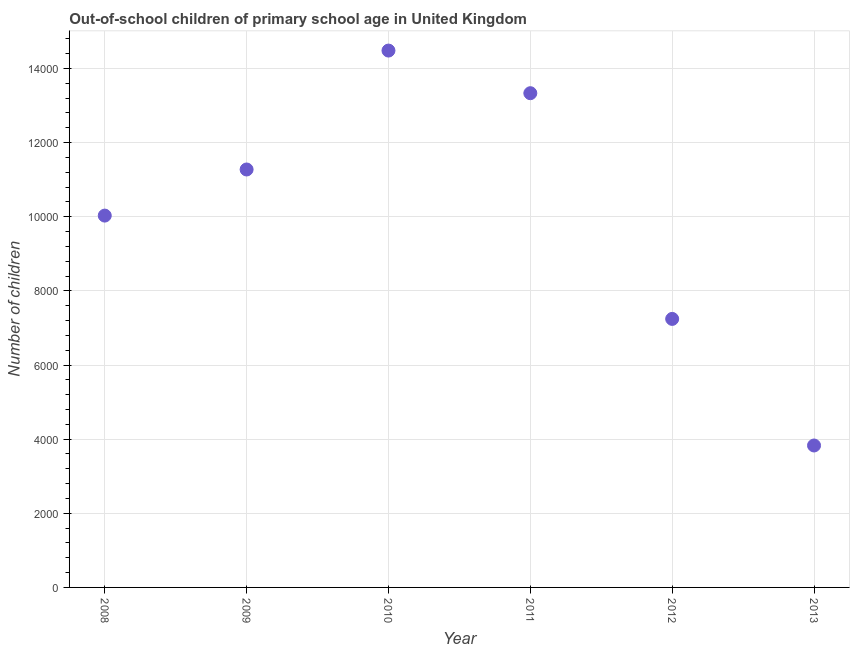What is the number of out-of-school children in 2010?
Your response must be concise. 1.45e+04. Across all years, what is the maximum number of out-of-school children?
Give a very brief answer. 1.45e+04. Across all years, what is the minimum number of out-of-school children?
Keep it short and to the point. 3829. In which year was the number of out-of-school children minimum?
Give a very brief answer. 2013. What is the sum of the number of out-of-school children?
Your answer should be compact. 6.02e+04. What is the difference between the number of out-of-school children in 2011 and 2012?
Ensure brevity in your answer.  6089. What is the average number of out-of-school children per year?
Your answer should be very brief. 1.00e+04. What is the median number of out-of-school children?
Your answer should be very brief. 1.07e+04. In how many years, is the number of out-of-school children greater than 400 ?
Keep it short and to the point. 6. Do a majority of the years between 2013 and 2010 (inclusive) have number of out-of-school children greater than 800 ?
Give a very brief answer. Yes. What is the ratio of the number of out-of-school children in 2008 to that in 2009?
Ensure brevity in your answer.  0.89. Is the number of out-of-school children in 2010 less than that in 2012?
Make the answer very short. No. Is the difference between the number of out-of-school children in 2008 and 2012 greater than the difference between any two years?
Your response must be concise. No. What is the difference between the highest and the second highest number of out-of-school children?
Your answer should be compact. 1150. What is the difference between the highest and the lowest number of out-of-school children?
Your answer should be very brief. 1.07e+04. In how many years, is the number of out-of-school children greater than the average number of out-of-school children taken over all years?
Your response must be concise. 3. Does the number of out-of-school children monotonically increase over the years?
Make the answer very short. No. How many dotlines are there?
Your response must be concise. 1. What is the difference between two consecutive major ticks on the Y-axis?
Ensure brevity in your answer.  2000. Are the values on the major ticks of Y-axis written in scientific E-notation?
Make the answer very short. No. Does the graph contain any zero values?
Ensure brevity in your answer.  No. What is the title of the graph?
Offer a terse response. Out-of-school children of primary school age in United Kingdom. What is the label or title of the Y-axis?
Make the answer very short. Number of children. What is the Number of children in 2008?
Ensure brevity in your answer.  1.00e+04. What is the Number of children in 2009?
Your response must be concise. 1.13e+04. What is the Number of children in 2010?
Your answer should be compact. 1.45e+04. What is the Number of children in 2011?
Your response must be concise. 1.33e+04. What is the Number of children in 2012?
Provide a short and direct response. 7244. What is the Number of children in 2013?
Ensure brevity in your answer.  3829. What is the difference between the Number of children in 2008 and 2009?
Make the answer very short. -1244. What is the difference between the Number of children in 2008 and 2010?
Offer a very short reply. -4452. What is the difference between the Number of children in 2008 and 2011?
Give a very brief answer. -3302. What is the difference between the Number of children in 2008 and 2012?
Provide a succinct answer. 2787. What is the difference between the Number of children in 2008 and 2013?
Provide a succinct answer. 6202. What is the difference between the Number of children in 2009 and 2010?
Keep it short and to the point. -3208. What is the difference between the Number of children in 2009 and 2011?
Ensure brevity in your answer.  -2058. What is the difference between the Number of children in 2009 and 2012?
Give a very brief answer. 4031. What is the difference between the Number of children in 2009 and 2013?
Your answer should be compact. 7446. What is the difference between the Number of children in 2010 and 2011?
Provide a succinct answer. 1150. What is the difference between the Number of children in 2010 and 2012?
Provide a short and direct response. 7239. What is the difference between the Number of children in 2010 and 2013?
Provide a succinct answer. 1.07e+04. What is the difference between the Number of children in 2011 and 2012?
Keep it short and to the point. 6089. What is the difference between the Number of children in 2011 and 2013?
Your answer should be compact. 9504. What is the difference between the Number of children in 2012 and 2013?
Ensure brevity in your answer.  3415. What is the ratio of the Number of children in 2008 to that in 2009?
Your answer should be very brief. 0.89. What is the ratio of the Number of children in 2008 to that in 2010?
Make the answer very short. 0.69. What is the ratio of the Number of children in 2008 to that in 2011?
Your answer should be compact. 0.75. What is the ratio of the Number of children in 2008 to that in 2012?
Offer a very short reply. 1.39. What is the ratio of the Number of children in 2008 to that in 2013?
Give a very brief answer. 2.62. What is the ratio of the Number of children in 2009 to that in 2010?
Provide a succinct answer. 0.78. What is the ratio of the Number of children in 2009 to that in 2011?
Your answer should be compact. 0.85. What is the ratio of the Number of children in 2009 to that in 2012?
Your answer should be very brief. 1.56. What is the ratio of the Number of children in 2009 to that in 2013?
Keep it short and to the point. 2.94. What is the ratio of the Number of children in 2010 to that in 2011?
Offer a terse response. 1.09. What is the ratio of the Number of children in 2010 to that in 2012?
Your answer should be compact. 2. What is the ratio of the Number of children in 2010 to that in 2013?
Give a very brief answer. 3.78. What is the ratio of the Number of children in 2011 to that in 2012?
Offer a very short reply. 1.84. What is the ratio of the Number of children in 2011 to that in 2013?
Give a very brief answer. 3.48. What is the ratio of the Number of children in 2012 to that in 2013?
Provide a short and direct response. 1.89. 